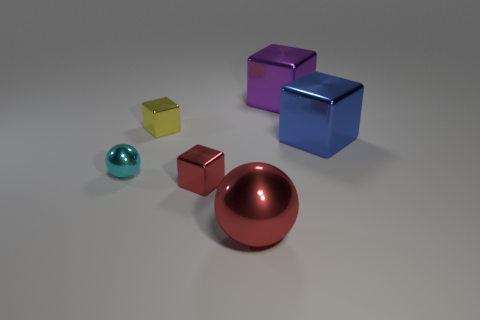What number of matte things are either large blocks or big purple objects? In the image, there is one large purple cube that has a matte finish. Therefore, the number of matte things that are either large blocks or big purple objects is 1. 